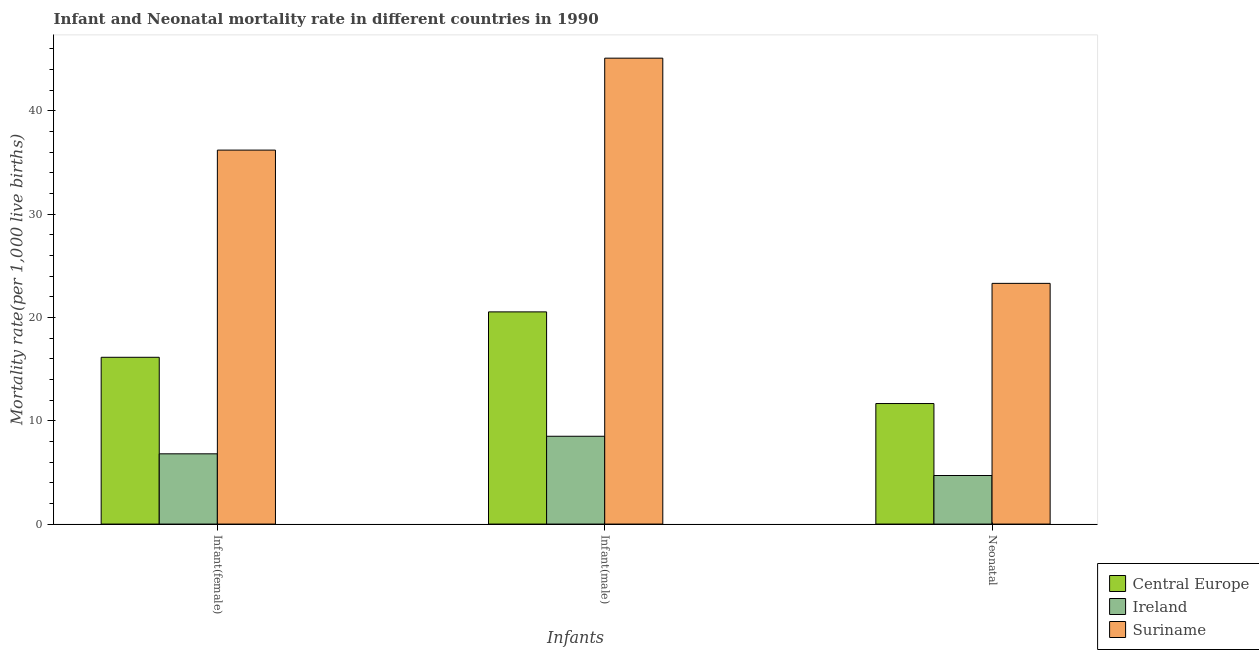How many groups of bars are there?
Your answer should be compact. 3. How many bars are there on the 1st tick from the left?
Your answer should be very brief. 3. How many bars are there on the 2nd tick from the right?
Offer a terse response. 3. What is the label of the 2nd group of bars from the left?
Ensure brevity in your answer.  Infant(male). What is the infant mortality rate(male) in Central Europe?
Provide a succinct answer. 20.54. Across all countries, what is the maximum infant mortality rate(female)?
Keep it short and to the point. 36.2. In which country was the neonatal mortality rate maximum?
Offer a terse response. Suriname. In which country was the infant mortality rate(male) minimum?
Keep it short and to the point. Ireland. What is the total neonatal mortality rate in the graph?
Give a very brief answer. 39.67. What is the difference between the neonatal mortality rate in Suriname and that in Ireland?
Your answer should be very brief. 18.6. What is the difference between the infant mortality rate(male) in Central Europe and the infant mortality rate(female) in Ireland?
Keep it short and to the point. 13.74. What is the average infant mortality rate(female) per country?
Your answer should be compact. 19.71. What is the difference between the infant mortality rate(female) and infant mortality rate(male) in Central Europe?
Your answer should be compact. -4.4. What is the ratio of the infant mortality rate(female) in Ireland to that in Suriname?
Provide a short and direct response. 0.19. Is the neonatal mortality rate in Central Europe less than that in Ireland?
Your response must be concise. No. Is the difference between the neonatal mortality rate in Central Europe and Suriname greater than the difference between the infant mortality rate(male) in Central Europe and Suriname?
Ensure brevity in your answer.  Yes. What is the difference between the highest and the second highest infant mortality rate(male)?
Your answer should be very brief. 24.56. What is the difference between the highest and the lowest infant mortality rate(female)?
Offer a very short reply. 29.4. In how many countries, is the infant mortality rate(female) greater than the average infant mortality rate(female) taken over all countries?
Your answer should be compact. 1. Is the sum of the infant mortality rate(female) in Ireland and Suriname greater than the maximum infant mortality rate(male) across all countries?
Offer a terse response. No. What does the 3rd bar from the left in Infant(male) represents?
Ensure brevity in your answer.  Suriname. What does the 2nd bar from the right in Infant(female) represents?
Provide a succinct answer. Ireland. How many bars are there?
Give a very brief answer. 9. Does the graph contain grids?
Ensure brevity in your answer.  No. Where does the legend appear in the graph?
Keep it short and to the point. Bottom right. What is the title of the graph?
Your answer should be compact. Infant and Neonatal mortality rate in different countries in 1990. What is the label or title of the X-axis?
Your answer should be compact. Infants. What is the label or title of the Y-axis?
Provide a succinct answer. Mortality rate(per 1,0 live births). What is the Mortality rate(per 1,000 live births) in Central Europe in Infant(female)?
Ensure brevity in your answer.  16.14. What is the Mortality rate(per 1,000 live births) of Ireland in Infant(female)?
Provide a succinct answer. 6.8. What is the Mortality rate(per 1,000 live births) of Suriname in Infant(female)?
Provide a succinct answer. 36.2. What is the Mortality rate(per 1,000 live births) of Central Europe in Infant(male)?
Give a very brief answer. 20.54. What is the Mortality rate(per 1,000 live births) in Suriname in Infant(male)?
Provide a succinct answer. 45.1. What is the Mortality rate(per 1,000 live births) in Central Europe in Neonatal ?
Offer a terse response. 11.67. What is the Mortality rate(per 1,000 live births) in Ireland in Neonatal ?
Give a very brief answer. 4.7. What is the Mortality rate(per 1,000 live births) of Suriname in Neonatal ?
Keep it short and to the point. 23.3. Across all Infants, what is the maximum Mortality rate(per 1,000 live births) of Central Europe?
Give a very brief answer. 20.54. Across all Infants, what is the maximum Mortality rate(per 1,000 live births) of Ireland?
Your response must be concise. 8.5. Across all Infants, what is the maximum Mortality rate(per 1,000 live births) in Suriname?
Provide a short and direct response. 45.1. Across all Infants, what is the minimum Mortality rate(per 1,000 live births) in Central Europe?
Offer a terse response. 11.67. Across all Infants, what is the minimum Mortality rate(per 1,000 live births) of Ireland?
Offer a terse response. 4.7. Across all Infants, what is the minimum Mortality rate(per 1,000 live births) in Suriname?
Keep it short and to the point. 23.3. What is the total Mortality rate(per 1,000 live births) of Central Europe in the graph?
Your answer should be very brief. 48.35. What is the total Mortality rate(per 1,000 live births) of Suriname in the graph?
Provide a succinct answer. 104.6. What is the difference between the Mortality rate(per 1,000 live births) in Central Europe in Infant(female) and that in Infant(male)?
Provide a short and direct response. -4.4. What is the difference between the Mortality rate(per 1,000 live births) of Ireland in Infant(female) and that in Infant(male)?
Offer a terse response. -1.7. What is the difference between the Mortality rate(per 1,000 live births) in Suriname in Infant(female) and that in Infant(male)?
Provide a succinct answer. -8.9. What is the difference between the Mortality rate(per 1,000 live births) in Central Europe in Infant(female) and that in Neonatal ?
Provide a short and direct response. 4.48. What is the difference between the Mortality rate(per 1,000 live births) in Central Europe in Infant(male) and that in Neonatal ?
Keep it short and to the point. 8.87. What is the difference between the Mortality rate(per 1,000 live births) in Ireland in Infant(male) and that in Neonatal ?
Your response must be concise. 3.8. What is the difference between the Mortality rate(per 1,000 live births) in Suriname in Infant(male) and that in Neonatal ?
Make the answer very short. 21.8. What is the difference between the Mortality rate(per 1,000 live births) of Central Europe in Infant(female) and the Mortality rate(per 1,000 live births) of Ireland in Infant(male)?
Your response must be concise. 7.64. What is the difference between the Mortality rate(per 1,000 live births) of Central Europe in Infant(female) and the Mortality rate(per 1,000 live births) of Suriname in Infant(male)?
Offer a very short reply. -28.96. What is the difference between the Mortality rate(per 1,000 live births) of Ireland in Infant(female) and the Mortality rate(per 1,000 live births) of Suriname in Infant(male)?
Make the answer very short. -38.3. What is the difference between the Mortality rate(per 1,000 live births) in Central Europe in Infant(female) and the Mortality rate(per 1,000 live births) in Ireland in Neonatal?
Keep it short and to the point. 11.44. What is the difference between the Mortality rate(per 1,000 live births) in Central Europe in Infant(female) and the Mortality rate(per 1,000 live births) in Suriname in Neonatal?
Your answer should be compact. -7.16. What is the difference between the Mortality rate(per 1,000 live births) of Ireland in Infant(female) and the Mortality rate(per 1,000 live births) of Suriname in Neonatal?
Your response must be concise. -16.5. What is the difference between the Mortality rate(per 1,000 live births) in Central Europe in Infant(male) and the Mortality rate(per 1,000 live births) in Ireland in Neonatal?
Your answer should be compact. 15.84. What is the difference between the Mortality rate(per 1,000 live births) of Central Europe in Infant(male) and the Mortality rate(per 1,000 live births) of Suriname in Neonatal?
Keep it short and to the point. -2.76. What is the difference between the Mortality rate(per 1,000 live births) in Ireland in Infant(male) and the Mortality rate(per 1,000 live births) in Suriname in Neonatal?
Provide a short and direct response. -14.8. What is the average Mortality rate(per 1,000 live births) in Central Europe per Infants?
Your answer should be very brief. 16.12. What is the average Mortality rate(per 1,000 live births) in Ireland per Infants?
Keep it short and to the point. 6.67. What is the average Mortality rate(per 1,000 live births) of Suriname per Infants?
Your answer should be compact. 34.87. What is the difference between the Mortality rate(per 1,000 live births) in Central Europe and Mortality rate(per 1,000 live births) in Ireland in Infant(female)?
Provide a succinct answer. 9.34. What is the difference between the Mortality rate(per 1,000 live births) of Central Europe and Mortality rate(per 1,000 live births) of Suriname in Infant(female)?
Make the answer very short. -20.06. What is the difference between the Mortality rate(per 1,000 live births) in Ireland and Mortality rate(per 1,000 live births) in Suriname in Infant(female)?
Offer a terse response. -29.4. What is the difference between the Mortality rate(per 1,000 live births) in Central Europe and Mortality rate(per 1,000 live births) in Ireland in Infant(male)?
Your answer should be compact. 12.04. What is the difference between the Mortality rate(per 1,000 live births) of Central Europe and Mortality rate(per 1,000 live births) of Suriname in Infant(male)?
Offer a very short reply. -24.56. What is the difference between the Mortality rate(per 1,000 live births) in Ireland and Mortality rate(per 1,000 live births) in Suriname in Infant(male)?
Give a very brief answer. -36.6. What is the difference between the Mortality rate(per 1,000 live births) in Central Europe and Mortality rate(per 1,000 live births) in Ireland in Neonatal ?
Offer a terse response. 6.97. What is the difference between the Mortality rate(per 1,000 live births) in Central Europe and Mortality rate(per 1,000 live births) in Suriname in Neonatal ?
Offer a terse response. -11.63. What is the difference between the Mortality rate(per 1,000 live births) in Ireland and Mortality rate(per 1,000 live births) in Suriname in Neonatal ?
Your answer should be very brief. -18.6. What is the ratio of the Mortality rate(per 1,000 live births) in Central Europe in Infant(female) to that in Infant(male)?
Offer a very short reply. 0.79. What is the ratio of the Mortality rate(per 1,000 live births) of Suriname in Infant(female) to that in Infant(male)?
Offer a terse response. 0.8. What is the ratio of the Mortality rate(per 1,000 live births) of Central Europe in Infant(female) to that in Neonatal ?
Offer a very short reply. 1.38. What is the ratio of the Mortality rate(per 1,000 live births) in Ireland in Infant(female) to that in Neonatal ?
Your answer should be very brief. 1.45. What is the ratio of the Mortality rate(per 1,000 live births) in Suriname in Infant(female) to that in Neonatal ?
Offer a terse response. 1.55. What is the ratio of the Mortality rate(per 1,000 live births) in Central Europe in Infant(male) to that in Neonatal ?
Give a very brief answer. 1.76. What is the ratio of the Mortality rate(per 1,000 live births) in Ireland in Infant(male) to that in Neonatal ?
Offer a very short reply. 1.81. What is the ratio of the Mortality rate(per 1,000 live births) in Suriname in Infant(male) to that in Neonatal ?
Offer a very short reply. 1.94. What is the difference between the highest and the second highest Mortality rate(per 1,000 live births) in Central Europe?
Your response must be concise. 4.4. What is the difference between the highest and the lowest Mortality rate(per 1,000 live births) of Central Europe?
Offer a very short reply. 8.87. What is the difference between the highest and the lowest Mortality rate(per 1,000 live births) in Suriname?
Your response must be concise. 21.8. 